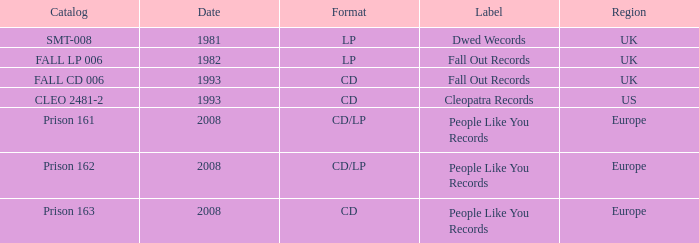Which Label has a Date smaller than 2008, and a Catalog of fall cd 006? Fall Out Records. 